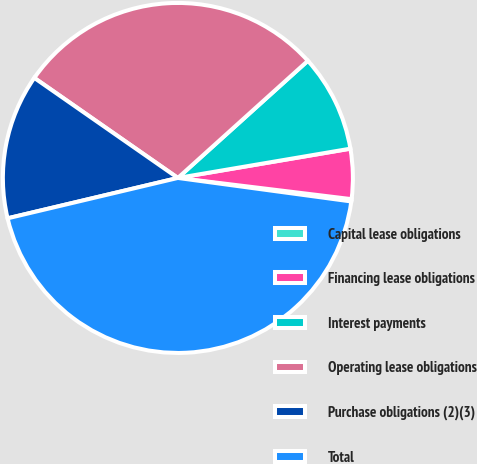Convert chart. <chart><loc_0><loc_0><loc_500><loc_500><pie_chart><fcel>Capital lease obligations<fcel>Financing lease obligations<fcel>Interest payments<fcel>Operating lease obligations<fcel>Purchase obligations (2)(3)<fcel>Total<nl><fcel>0.21%<fcel>4.61%<fcel>9.0%<fcel>28.64%<fcel>13.39%<fcel>44.15%<nl></chart> 